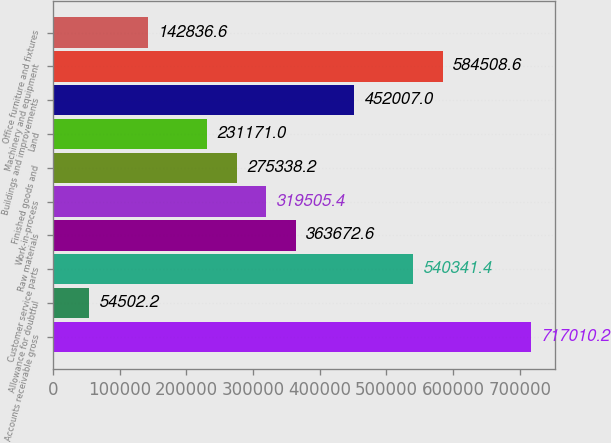Convert chart. <chart><loc_0><loc_0><loc_500><loc_500><bar_chart><fcel>Accounts receivable gross<fcel>Allowance for doubtful<fcel>Customer service parts<fcel>Raw materials<fcel>Work-in-process<fcel>Finished goods and<fcel>Land<fcel>Buildings and improvements<fcel>Machinery and equipment<fcel>Office furniture and fixtures<nl><fcel>717010<fcel>54502.2<fcel>540341<fcel>363673<fcel>319505<fcel>275338<fcel>231171<fcel>452007<fcel>584509<fcel>142837<nl></chart> 